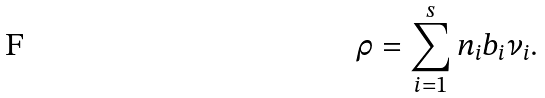<formula> <loc_0><loc_0><loc_500><loc_500>\rho = \sum _ { i = 1 } ^ { s } n _ { i } b _ { i } \nu _ { i } .</formula> 